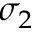Convert formula to latex. <formula><loc_0><loc_0><loc_500><loc_500>\sigma _ { 2 }</formula> 